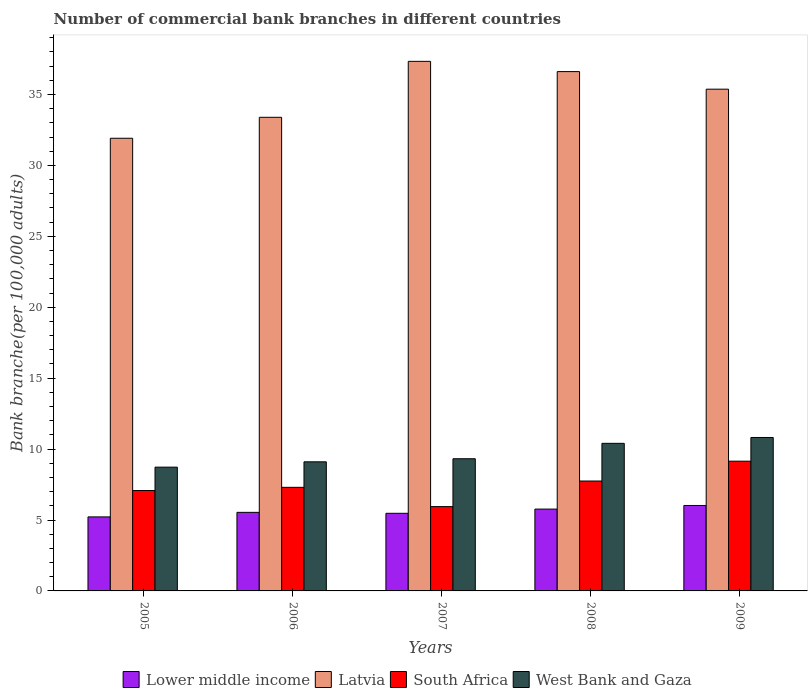Are the number of bars per tick equal to the number of legend labels?
Provide a succinct answer. Yes. Are the number of bars on each tick of the X-axis equal?
Offer a very short reply. Yes. How many bars are there on the 1st tick from the left?
Keep it short and to the point. 4. How many bars are there on the 5th tick from the right?
Offer a very short reply. 4. What is the label of the 2nd group of bars from the left?
Ensure brevity in your answer.  2006. What is the number of commercial bank branches in South Africa in 2006?
Keep it short and to the point. 7.3. Across all years, what is the maximum number of commercial bank branches in Latvia?
Your response must be concise. 37.34. Across all years, what is the minimum number of commercial bank branches in West Bank and Gaza?
Your response must be concise. 8.73. What is the total number of commercial bank branches in South Africa in the graph?
Your response must be concise. 37.22. What is the difference between the number of commercial bank branches in South Africa in 2005 and that in 2009?
Offer a very short reply. -2.07. What is the difference between the number of commercial bank branches in Latvia in 2008 and the number of commercial bank branches in West Bank and Gaza in 2005?
Offer a very short reply. 27.89. What is the average number of commercial bank branches in Lower middle income per year?
Give a very brief answer. 5.6. In the year 2007, what is the difference between the number of commercial bank branches in West Bank and Gaza and number of commercial bank branches in South Africa?
Offer a terse response. 3.38. What is the ratio of the number of commercial bank branches in South Africa in 2007 to that in 2009?
Make the answer very short. 0.65. Is the number of commercial bank branches in Latvia in 2007 less than that in 2008?
Your response must be concise. No. Is the difference between the number of commercial bank branches in West Bank and Gaza in 2005 and 2009 greater than the difference between the number of commercial bank branches in South Africa in 2005 and 2009?
Make the answer very short. No. What is the difference between the highest and the second highest number of commercial bank branches in Latvia?
Offer a terse response. 0.72. What is the difference between the highest and the lowest number of commercial bank branches in South Africa?
Keep it short and to the point. 3.2. What does the 2nd bar from the left in 2009 represents?
Give a very brief answer. Latvia. What does the 4th bar from the right in 2006 represents?
Provide a short and direct response. Lower middle income. How many bars are there?
Make the answer very short. 20. Are the values on the major ticks of Y-axis written in scientific E-notation?
Your answer should be very brief. No. Does the graph contain grids?
Keep it short and to the point. No. Where does the legend appear in the graph?
Provide a short and direct response. Bottom center. How many legend labels are there?
Your answer should be compact. 4. What is the title of the graph?
Keep it short and to the point. Number of commercial bank branches in different countries. Does "Togo" appear as one of the legend labels in the graph?
Offer a terse response. No. What is the label or title of the X-axis?
Offer a very short reply. Years. What is the label or title of the Y-axis?
Offer a terse response. Bank branche(per 100,0 adults). What is the Bank branche(per 100,000 adults) of Lower middle income in 2005?
Give a very brief answer. 5.22. What is the Bank branche(per 100,000 adults) in Latvia in 2005?
Provide a succinct answer. 31.92. What is the Bank branche(per 100,000 adults) of South Africa in 2005?
Ensure brevity in your answer.  7.08. What is the Bank branche(per 100,000 adults) in West Bank and Gaza in 2005?
Your answer should be compact. 8.73. What is the Bank branche(per 100,000 adults) of Lower middle income in 2006?
Give a very brief answer. 5.54. What is the Bank branche(per 100,000 adults) of Latvia in 2006?
Offer a very short reply. 33.39. What is the Bank branche(per 100,000 adults) of South Africa in 2006?
Keep it short and to the point. 7.3. What is the Bank branche(per 100,000 adults) in West Bank and Gaza in 2006?
Provide a succinct answer. 9.1. What is the Bank branche(per 100,000 adults) of Lower middle income in 2007?
Offer a terse response. 5.47. What is the Bank branche(per 100,000 adults) of Latvia in 2007?
Offer a very short reply. 37.34. What is the Bank branche(per 100,000 adults) of South Africa in 2007?
Offer a very short reply. 5.94. What is the Bank branche(per 100,000 adults) in West Bank and Gaza in 2007?
Offer a terse response. 9.32. What is the Bank branche(per 100,000 adults) in Lower middle income in 2008?
Provide a short and direct response. 5.77. What is the Bank branche(per 100,000 adults) of Latvia in 2008?
Offer a terse response. 36.62. What is the Bank branche(per 100,000 adults) in South Africa in 2008?
Your answer should be compact. 7.75. What is the Bank branche(per 100,000 adults) of West Bank and Gaza in 2008?
Provide a short and direct response. 10.41. What is the Bank branche(per 100,000 adults) of Lower middle income in 2009?
Keep it short and to the point. 6.02. What is the Bank branche(per 100,000 adults) of Latvia in 2009?
Provide a short and direct response. 35.38. What is the Bank branche(per 100,000 adults) of South Africa in 2009?
Keep it short and to the point. 9.15. What is the Bank branche(per 100,000 adults) of West Bank and Gaza in 2009?
Your answer should be compact. 10.82. Across all years, what is the maximum Bank branche(per 100,000 adults) in Lower middle income?
Your answer should be compact. 6.02. Across all years, what is the maximum Bank branche(per 100,000 adults) of Latvia?
Provide a succinct answer. 37.34. Across all years, what is the maximum Bank branche(per 100,000 adults) in South Africa?
Give a very brief answer. 9.15. Across all years, what is the maximum Bank branche(per 100,000 adults) of West Bank and Gaza?
Offer a very short reply. 10.82. Across all years, what is the minimum Bank branche(per 100,000 adults) of Lower middle income?
Offer a very short reply. 5.22. Across all years, what is the minimum Bank branche(per 100,000 adults) in Latvia?
Your answer should be very brief. 31.92. Across all years, what is the minimum Bank branche(per 100,000 adults) in South Africa?
Provide a short and direct response. 5.94. Across all years, what is the minimum Bank branche(per 100,000 adults) of West Bank and Gaza?
Provide a succinct answer. 8.73. What is the total Bank branche(per 100,000 adults) in Lower middle income in the graph?
Ensure brevity in your answer.  28.02. What is the total Bank branche(per 100,000 adults) of Latvia in the graph?
Your answer should be very brief. 174.64. What is the total Bank branche(per 100,000 adults) in South Africa in the graph?
Your answer should be compact. 37.22. What is the total Bank branche(per 100,000 adults) of West Bank and Gaza in the graph?
Offer a very short reply. 48.37. What is the difference between the Bank branche(per 100,000 adults) in Lower middle income in 2005 and that in 2006?
Your answer should be compact. -0.32. What is the difference between the Bank branche(per 100,000 adults) of Latvia in 2005 and that in 2006?
Your response must be concise. -1.48. What is the difference between the Bank branche(per 100,000 adults) in South Africa in 2005 and that in 2006?
Your answer should be compact. -0.23. What is the difference between the Bank branche(per 100,000 adults) in West Bank and Gaza in 2005 and that in 2006?
Your response must be concise. -0.37. What is the difference between the Bank branche(per 100,000 adults) in Lower middle income in 2005 and that in 2007?
Keep it short and to the point. -0.25. What is the difference between the Bank branche(per 100,000 adults) of Latvia in 2005 and that in 2007?
Give a very brief answer. -5.42. What is the difference between the Bank branche(per 100,000 adults) in South Africa in 2005 and that in 2007?
Keep it short and to the point. 1.13. What is the difference between the Bank branche(per 100,000 adults) in West Bank and Gaza in 2005 and that in 2007?
Give a very brief answer. -0.59. What is the difference between the Bank branche(per 100,000 adults) in Lower middle income in 2005 and that in 2008?
Your response must be concise. -0.55. What is the difference between the Bank branche(per 100,000 adults) of Latvia in 2005 and that in 2008?
Keep it short and to the point. -4.7. What is the difference between the Bank branche(per 100,000 adults) in South Africa in 2005 and that in 2008?
Keep it short and to the point. -0.67. What is the difference between the Bank branche(per 100,000 adults) of West Bank and Gaza in 2005 and that in 2008?
Your answer should be very brief. -1.68. What is the difference between the Bank branche(per 100,000 adults) of Lower middle income in 2005 and that in 2009?
Your answer should be very brief. -0.81. What is the difference between the Bank branche(per 100,000 adults) of Latvia in 2005 and that in 2009?
Provide a succinct answer. -3.46. What is the difference between the Bank branche(per 100,000 adults) in South Africa in 2005 and that in 2009?
Provide a short and direct response. -2.07. What is the difference between the Bank branche(per 100,000 adults) in West Bank and Gaza in 2005 and that in 2009?
Provide a succinct answer. -2.09. What is the difference between the Bank branche(per 100,000 adults) of Lower middle income in 2006 and that in 2007?
Make the answer very short. 0.07. What is the difference between the Bank branche(per 100,000 adults) of Latvia in 2006 and that in 2007?
Give a very brief answer. -3.94. What is the difference between the Bank branche(per 100,000 adults) of South Africa in 2006 and that in 2007?
Your answer should be compact. 1.36. What is the difference between the Bank branche(per 100,000 adults) of West Bank and Gaza in 2006 and that in 2007?
Offer a terse response. -0.22. What is the difference between the Bank branche(per 100,000 adults) of Lower middle income in 2006 and that in 2008?
Provide a succinct answer. -0.23. What is the difference between the Bank branche(per 100,000 adults) of Latvia in 2006 and that in 2008?
Offer a terse response. -3.22. What is the difference between the Bank branche(per 100,000 adults) in South Africa in 2006 and that in 2008?
Give a very brief answer. -0.45. What is the difference between the Bank branche(per 100,000 adults) in West Bank and Gaza in 2006 and that in 2008?
Offer a very short reply. -1.3. What is the difference between the Bank branche(per 100,000 adults) of Lower middle income in 2006 and that in 2009?
Offer a very short reply. -0.48. What is the difference between the Bank branche(per 100,000 adults) in Latvia in 2006 and that in 2009?
Make the answer very short. -1.98. What is the difference between the Bank branche(per 100,000 adults) in South Africa in 2006 and that in 2009?
Keep it short and to the point. -1.84. What is the difference between the Bank branche(per 100,000 adults) of West Bank and Gaza in 2006 and that in 2009?
Your answer should be compact. -1.72. What is the difference between the Bank branche(per 100,000 adults) of Lower middle income in 2007 and that in 2008?
Offer a very short reply. -0.3. What is the difference between the Bank branche(per 100,000 adults) in Latvia in 2007 and that in 2008?
Ensure brevity in your answer.  0.72. What is the difference between the Bank branche(per 100,000 adults) of South Africa in 2007 and that in 2008?
Make the answer very short. -1.8. What is the difference between the Bank branche(per 100,000 adults) in West Bank and Gaza in 2007 and that in 2008?
Your answer should be compact. -1.09. What is the difference between the Bank branche(per 100,000 adults) in Lower middle income in 2007 and that in 2009?
Offer a terse response. -0.55. What is the difference between the Bank branche(per 100,000 adults) in Latvia in 2007 and that in 2009?
Provide a succinct answer. 1.96. What is the difference between the Bank branche(per 100,000 adults) in South Africa in 2007 and that in 2009?
Offer a terse response. -3.2. What is the difference between the Bank branche(per 100,000 adults) of West Bank and Gaza in 2007 and that in 2009?
Your response must be concise. -1.5. What is the difference between the Bank branche(per 100,000 adults) in Lower middle income in 2008 and that in 2009?
Offer a very short reply. -0.25. What is the difference between the Bank branche(per 100,000 adults) in Latvia in 2008 and that in 2009?
Give a very brief answer. 1.24. What is the difference between the Bank branche(per 100,000 adults) in South Africa in 2008 and that in 2009?
Keep it short and to the point. -1.4. What is the difference between the Bank branche(per 100,000 adults) of West Bank and Gaza in 2008 and that in 2009?
Your answer should be compact. -0.41. What is the difference between the Bank branche(per 100,000 adults) in Lower middle income in 2005 and the Bank branche(per 100,000 adults) in Latvia in 2006?
Make the answer very short. -28.17. What is the difference between the Bank branche(per 100,000 adults) of Lower middle income in 2005 and the Bank branche(per 100,000 adults) of South Africa in 2006?
Make the answer very short. -2.08. What is the difference between the Bank branche(per 100,000 adults) in Lower middle income in 2005 and the Bank branche(per 100,000 adults) in West Bank and Gaza in 2006?
Your answer should be compact. -3.88. What is the difference between the Bank branche(per 100,000 adults) in Latvia in 2005 and the Bank branche(per 100,000 adults) in South Africa in 2006?
Your answer should be very brief. 24.61. What is the difference between the Bank branche(per 100,000 adults) of Latvia in 2005 and the Bank branche(per 100,000 adults) of West Bank and Gaza in 2006?
Keep it short and to the point. 22.81. What is the difference between the Bank branche(per 100,000 adults) in South Africa in 2005 and the Bank branche(per 100,000 adults) in West Bank and Gaza in 2006?
Provide a short and direct response. -2.02. What is the difference between the Bank branche(per 100,000 adults) of Lower middle income in 2005 and the Bank branche(per 100,000 adults) of Latvia in 2007?
Provide a short and direct response. -32.12. What is the difference between the Bank branche(per 100,000 adults) of Lower middle income in 2005 and the Bank branche(per 100,000 adults) of South Africa in 2007?
Make the answer very short. -0.73. What is the difference between the Bank branche(per 100,000 adults) of Lower middle income in 2005 and the Bank branche(per 100,000 adults) of West Bank and Gaza in 2007?
Offer a very short reply. -4.1. What is the difference between the Bank branche(per 100,000 adults) of Latvia in 2005 and the Bank branche(per 100,000 adults) of South Africa in 2007?
Give a very brief answer. 25.97. What is the difference between the Bank branche(per 100,000 adults) of Latvia in 2005 and the Bank branche(per 100,000 adults) of West Bank and Gaza in 2007?
Make the answer very short. 22.6. What is the difference between the Bank branche(per 100,000 adults) in South Africa in 2005 and the Bank branche(per 100,000 adults) in West Bank and Gaza in 2007?
Your answer should be compact. -2.24. What is the difference between the Bank branche(per 100,000 adults) of Lower middle income in 2005 and the Bank branche(per 100,000 adults) of Latvia in 2008?
Ensure brevity in your answer.  -31.4. What is the difference between the Bank branche(per 100,000 adults) in Lower middle income in 2005 and the Bank branche(per 100,000 adults) in South Africa in 2008?
Ensure brevity in your answer.  -2.53. What is the difference between the Bank branche(per 100,000 adults) of Lower middle income in 2005 and the Bank branche(per 100,000 adults) of West Bank and Gaza in 2008?
Offer a very short reply. -5.19. What is the difference between the Bank branche(per 100,000 adults) of Latvia in 2005 and the Bank branche(per 100,000 adults) of South Africa in 2008?
Give a very brief answer. 24.17. What is the difference between the Bank branche(per 100,000 adults) of Latvia in 2005 and the Bank branche(per 100,000 adults) of West Bank and Gaza in 2008?
Your response must be concise. 21.51. What is the difference between the Bank branche(per 100,000 adults) of South Africa in 2005 and the Bank branche(per 100,000 adults) of West Bank and Gaza in 2008?
Your answer should be very brief. -3.33. What is the difference between the Bank branche(per 100,000 adults) of Lower middle income in 2005 and the Bank branche(per 100,000 adults) of Latvia in 2009?
Provide a succinct answer. -30.16. What is the difference between the Bank branche(per 100,000 adults) of Lower middle income in 2005 and the Bank branche(per 100,000 adults) of South Africa in 2009?
Give a very brief answer. -3.93. What is the difference between the Bank branche(per 100,000 adults) in Latvia in 2005 and the Bank branche(per 100,000 adults) in South Africa in 2009?
Your answer should be compact. 22.77. What is the difference between the Bank branche(per 100,000 adults) in Latvia in 2005 and the Bank branche(per 100,000 adults) in West Bank and Gaza in 2009?
Make the answer very short. 21.1. What is the difference between the Bank branche(per 100,000 adults) in South Africa in 2005 and the Bank branche(per 100,000 adults) in West Bank and Gaza in 2009?
Ensure brevity in your answer.  -3.74. What is the difference between the Bank branche(per 100,000 adults) of Lower middle income in 2006 and the Bank branche(per 100,000 adults) of Latvia in 2007?
Give a very brief answer. -31.8. What is the difference between the Bank branche(per 100,000 adults) in Lower middle income in 2006 and the Bank branche(per 100,000 adults) in South Africa in 2007?
Offer a terse response. -0.4. What is the difference between the Bank branche(per 100,000 adults) in Lower middle income in 2006 and the Bank branche(per 100,000 adults) in West Bank and Gaza in 2007?
Offer a very short reply. -3.78. What is the difference between the Bank branche(per 100,000 adults) of Latvia in 2006 and the Bank branche(per 100,000 adults) of South Africa in 2007?
Offer a terse response. 27.45. What is the difference between the Bank branche(per 100,000 adults) of Latvia in 2006 and the Bank branche(per 100,000 adults) of West Bank and Gaza in 2007?
Your answer should be very brief. 24.07. What is the difference between the Bank branche(per 100,000 adults) in South Africa in 2006 and the Bank branche(per 100,000 adults) in West Bank and Gaza in 2007?
Offer a terse response. -2.02. What is the difference between the Bank branche(per 100,000 adults) in Lower middle income in 2006 and the Bank branche(per 100,000 adults) in Latvia in 2008?
Your response must be concise. -31.08. What is the difference between the Bank branche(per 100,000 adults) of Lower middle income in 2006 and the Bank branche(per 100,000 adults) of South Africa in 2008?
Make the answer very short. -2.21. What is the difference between the Bank branche(per 100,000 adults) of Lower middle income in 2006 and the Bank branche(per 100,000 adults) of West Bank and Gaza in 2008?
Provide a short and direct response. -4.87. What is the difference between the Bank branche(per 100,000 adults) in Latvia in 2006 and the Bank branche(per 100,000 adults) in South Africa in 2008?
Ensure brevity in your answer.  25.64. What is the difference between the Bank branche(per 100,000 adults) in Latvia in 2006 and the Bank branche(per 100,000 adults) in West Bank and Gaza in 2008?
Your answer should be very brief. 22.99. What is the difference between the Bank branche(per 100,000 adults) in South Africa in 2006 and the Bank branche(per 100,000 adults) in West Bank and Gaza in 2008?
Give a very brief answer. -3.1. What is the difference between the Bank branche(per 100,000 adults) of Lower middle income in 2006 and the Bank branche(per 100,000 adults) of Latvia in 2009?
Offer a terse response. -29.84. What is the difference between the Bank branche(per 100,000 adults) of Lower middle income in 2006 and the Bank branche(per 100,000 adults) of South Africa in 2009?
Give a very brief answer. -3.61. What is the difference between the Bank branche(per 100,000 adults) in Lower middle income in 2006 and the Bank branche(per 100,000 adults) in West Bank and Gaza in 2009?
Ensure brevity in your answer.  -5.28. What is the difference between the Bank branche(per 100,000 adults) in Latvia in 2006 and the Bank branche(per 100,000 adults) in South Africa in 2009?
Ensure brevity in your answer.  24.25. What is the difference between the Bank branche(per 100,000 adults) of Latvia in 2006 and the Bank branche(per 100,000 adults) of West Bank and Gaza in 2009?
Provide a short and direct response. 22.57. What is the difference between the Bank branche(per 100,000 adults) of South Africa in 2006 and the Bank branche(per 100,000 adults) of West Bank and Gaza in 2009?
Offer a very short reply. -3.52. What is the difference between the Bank branche(per 100,000 adults) in Lower middle income in 2007 and the Bank branche(per 100,000 adults) in Latvia in 2008?
Keep it short and to the point. -31.14. What is the difference between the Bank branche(per 100,000 adults) of Lower middle income in 2007 and the Bank branche(per 100,000 adults) of South Africa in 2008?
Your answer should be very brief. -2.28. What is the difference between the Bank branche(per 100,000 adults) of Lower middle income in 2007 and the Bank branche(per 100,000 adults) of West Bank and Gaza in 2008?
Keep it short and to the point. -4.93. What is the difference between the Bank branche(per 100,000 adults) in Latvia in 2007 and the Bank branche(per 100,000 adults) in South Africa in 2008?
Keep it short and to the point. 29.59. What is the difference between the Bank branche(per 100,000 adults) in Latvia in 2007 and the Bank branche(per 100,000 adults) in West Bank and Gaza in 2008?
Make the answer very short. 26.93. What is the difference between the Bank branche(per 100,000 adults) in South Africa in 2007 and the Bank branche(per 100,000 adults) in West Bank and Gaza in 2008?
Ensure brevity in your answer.  -4.46. What is the difference between the Bank branche(per 100,000 adults) in Lower middle income in 2007 and the Bank branche(per 100,000 adults) in Latvia in 2009?
Your answer should be very brief. -29.9. What is the difference between the Bank branche(per 100,000 adults) in Lower middle income in 2007 and the Bank branche(per 100,000 adults) in South Africa in 2009?
Your response must be concise. -3.68. What is the difference between the Bank branche(per 100,000 adults) of Lower middle income in 2007 and the Bank branche(per 100,000 adults) of West Bank and Gaza in 2009?
Provide a succinct answer. -5.35. What is the difference between the Bank branche(per 100,000 adults) in Latvia in 2007 and the Bank branche(per 100,000 adults) in South Africa in 2009?
Make the answer very short. 28.19. What is the difference between the Bank branche(per 100,000 adults) of Latvia in 2007 and the Bank branche(per 100,000 adults) of West Bank and Gaza in 2009?
Offer a terse response. 26.52. What is the difference between the Bank branche(per 100,000 adults) of South Africa in 2007 and the Bank branche(per 100,000 adults) of West Bank and Gaza in 2009?
Offer a very short reply. -4.87. What is the difference between the Bank branche(per 100,000 adults) of Lower middle income in 2008 and the Bank branche(per 100,000 adults) of Latvia in 2009?
Offer a terse response. -29.61. What is the difference between the Bank branche(per 100,000 adults) of Lower middle income in 2008 and the Bank branche(per 100,000 adults) of South Africa in 2009?
Provide a succinct answer. -3.38. What is the difference between the Bank branche(per 100,000 adults) in Lower middle income in 2008 and the Bank branche(per 100,000 adults) in West Bank and Gaza in 2009?
Provide a succinct answer. -5.05. What is the difference between the Bank branche(per 100,000 adults) of Latvia in 2008 and the Bank branche(per 100,000 adults) of South Africa in 2009?
Your answer should be very brief. 27.47. What is the difference between the Bank branche(per 100,000 adults) in Latvia in 2008 and the Bank branche(per 100,000 adults) in West Bank and Gaza in 2009?
Provide a succinct answer. 25.8. What is the difference between the Bank branche(per 100,000 adults) in South Africa in 2008 and the Bank branche(per 100,000 adults) in West Bank and Gaza in 2009?
Offer a very short reply. -3.07. What is the average Bank branche(per 100,000 adults) of Lower middle income per year?
Provide a succinct answer. 5.61. What is the average Bank branche(per 100,000 adults) in Latvia per year?
Offer a very short reply. 34.93. What is the average Bank branche(per 100,000 adults) of South Africa per year?
Offer a very short reply. 7.44. What is the average Bank branche(per 100,000 adults) of West Bank and Gaza per year?
Offer a terse response. 9.67. In the year 2005, what is the difference between the Bank branche(per 100,000 adults) in Lower middle income and Bank branche(per 100,000 adults) in Latvia?
Provide a short and direct response. -26.7. In the year 2005, what is the difference between the Bank branche(per 100,000 adults) in Lower middle income and Bank branche(per 100,000 adults) in South Africa?
Give a very brief answer. -1.86. In the year 2005, what is the difference between the Bank branche(per 100,000 adults) of Lower middle income and Bank branche(per 100,000 adults) of West Bank and Gaza?
Offer a very short reply. -3.51. In the year 2005, what is the difference between the Bank branche(per 100,000 adults) in Latvia and Bank branche(per 100,000 adults) in South Africa?
Provide a short and direct response. 24.84. In the year 2005, what is the difference between the Bank branche(per 100,000 adults) in Latvia and Bank branche(per 100,000 adults) in West Bank and Gaza?
Provide a short and direct response. 23.19. In the year 2005, what is the difference between the Bank branche(per 100,000 adults) in South Africa and Bank branche(per 100,000 adults) in West Bank and Gaza?
Offer a very short reply. -1.65. In the year 2006, what is the difference between the Bank branche(per 100,000 adults) of Lower middle income and Bank branche(per 100,000 adults) of Latvia?
Ensure brevity in your answer.  -27.85. In the year 2006, what is the difference between the Bank branche(per 100,000 adults) of Lower middle income and Bank branche(per 100,000 adults) of South Africa?
Ensure brevity in your answer.  -1.76. In the year 2006, what is the difference between the Bank branche(per 100,000 adults) in Lower middle income and Bank branche(per 100,000 adults) in West Bank and Gaza?
Your answer should be compact. -3.56. In the year 2006, what is the difference between the Bank branche(per 100,000 adults) of Latvia and Bank branche(per 100,000 adults) of South Africa?
Offer a very short reply. 26.09. In the year 2006, what is the difference between the Bank branche(per 100,000 adults) in Latvia and Bank branche(per 100,000 adults) in West Bank and Gaza?
Give a very brief answer. 24.29. In the year 2006, what is the difference between the Bank branche(per 100,000 adults) of South Africa and Bank branche(per 100,000 adults) of West Bank and Gaza?
Your answer should be compact. -1.8. In the year 2007, what is the difference between the Bank branche(per 100,000 adults) in Lower middle income and Bank branche(per 100,000 adults) in Latvia?
Keep it short and to the point. -31.87. In the year 2007, what is the difference between the Bank branche(per 100,000 adults) in Lower middle income and Bank branche(per 100,000 adults) in South Africa?
Ensure brevity in your answer.  -0.47. In the year 2007, what is the difference between the Bank branche(per 100,000 adults) in Lower middle income and Bank branche(per 100,000 adults) in West Bank and Gaza?
Give a very brief answer. -3.85. In the year 2007, what is the difference between the Bank branche(per 100,000 adults) of Latvia and Bank branche(per 100,000 adults) of South Africa?
Offer a terse response. 31.39. In the year 2007, what is the difference between the Bank branche(per 100,000 adults) of Latvia and Bank branche(per 100,000 adults) of West Bank and Gaza?
Your answer should be very brief. 28.02. In the year 2007, what is the difference between the Bank branche(per 100,000 adults) in South Africa and Bank branche(per 100,000 adults) in West Bank and Gaza?
Make the answer very short. -3.38. In the year 2008, what is the difference between the Bank branche(per 100,000 adults) of Lower middle income and Bank branche(per 100,000 adults) of Latvia?
Give a very brief answer. -30.85. In the year 2008, what is the difference between the Bank branche(per 100,000 adults) in Lower middle income and Bank branche(per 100,000 adults) in South Africa?
Provide a succinct answer. -1.98. In the year 2008, what is the difference between the Bank branche(per 100,000 adults) of Lower middle income and Bank branche(per 100,000 adults) of West Bank and Gaza?
Give a very brief answer. -4.64. In the year 2008, what is the difference between the Bank branche(per 100,000 adults) in Latvia and Bank branche(per 100,000 adults) in South Africa?
Make the answer very short. 28.87. In the year 2008, what is the difference between the Bank branche(per 100,000 adults) of Latvia and Bank branche(per 100,000 adults) of West Bank and Gaza?
Provide a short and direct response. 26.21. In the year 2008, what is the difference between the Bank branche(per 100,000 adults) of South Africa and Bank branche(per 100,000 adults) of West Bank and Gaza?
Make the answer very short. -2.66. In the year 2009, what is the difference between the Bank branche(per 100,000 adults) in Lower middle income and Bank branche(per 100,000 adults) in Latvia?
Your answer should be compact. -29.35. In the year 2009, what is the difference between the Bank branche(per 100,000 adults) in Lower middle income and Bank branche(per 100,000 adults) in South Africa?
Your response must be concise. -3.12. In the year 2009, what is the difference between the Bank branche(per 100,000 adults) of Lower middle income and Bank branche(per 100,000 adults) of West Bank and Gaza?
Keep it short and to the point. -4.79. In the year 2009, what is the difference between the Bank branche(per 100,000 adults) of Latvia and Bank branche(per 100,000 adults) of South Africa?
Your response must be concise. 26.23. In the year 2009, what is the difference between the Bank branche(per 100,000 adults) of Latvia and Bank branche(per 100,000 adults) of West Bank and Gaza?
Ensure brevity in your answer.  24.56. In the year 2009, what is the difference between the Bank branche(per 100,000 adults) of South Africa and Bank branche(per 100,000 adults) of West Bank and Gaza?
Provide a succinct answer. -1.67. What is the ratio of the Bank branche(per 100,000 adults) of Lower middle income in 2005 to that in 2006?
Your answer should be very brief. 0.94. What is the ratio of the Bank branche(per 100,000 adults) in Latvia in 2005 to that in 2006?
Your answer should be compact. 0.96. What is the ratio of the Bank branche(per 100,000 adults) of South Africa in 2005 to that in 2006?
Give a very brief answer. 0.97. What is the ratio of the Bank branche(per 100,000 adults) of West Bank and Gaza in 2005 to that in 2006?
Provide a short and direct response. 0.96. What is the ratio of the Bank branche(per 100,000 adults) in Lower middle income in 2005 to that in 2007?
Make the answer very short. 0.95. What is the ratio of the Bank branche(per 100,000 adults) in Latvia in 2005 to that in 2007?
Keep it short and to the point. 0.85. What is the ratio of the Bank branche(per 100,000 adults) in South Africa in 2005 to that in 2007?
Your answer should be compact. 1.19. What is the ratio of the Bank branche(per 100,000 adults) of West Bank and Gaza in 2005 to that in 2007?
Provide a short and direct response. 0.94. What is the ratio of the Bank branche(per 100,000 adults) in Lower middle income in 2005 to that in 2008?
Provide a short and direct response. 0.9. What is the ratio of the Bank branche(per 100,000 adults) of Latvia in 2005 to that in 2008?
Offer a terse response. 0.87. What is the ratio of the Bank branche(per 100,000 adults) of South Africa in 2005 to that in 2008?
Your answer should be very brief. 0.91. What is the ratio of the Bank branche(per 100,000 adults) in West Bank and Gaza in 2005 to that in 2008?
Provide a succinct answer. 0.84. What is the ratio of the Bank branche(per 100,000 adults) of Lower middle income in 2005 to that in 2009?
Provide a succinct answer. 0.87. What is the ratio of the Bank branche(per 100,000 adults) in Latvia in 2005 to that in 2009?
Your answer should be compact. 0.9. What is the ratio of the Bank branche(per 100,000 adults) of South Africa in 2005 to that in 2009?
Provide a short and direct response. 0.77. What is the ratio of the Bank branche(per 100,000 adults) in West Bank and Gaza in 2005 to that in 2009?
Your answer should be compact. 0.81. What is the ratio of the Bank branche(per 100,000 adults) in Lower middle income in 2006 to that in 2007?
Make the answer very short. 1.01. What is the ratio of the Bank branche(per 100,000 adults) in Latvia in 2006 to that in 2007?
Keep it short and to the point. 0.89. What is the ratio of the Bank branche(per 100,000 adults) in South Africa in 2006 to that in 2007?
Ensure brevity in your answer.  1.23. What is the ratio of the Bank branche(per 100,000 adults) in West Bank and Gaza in 2006 to that in 2007?
Make the answer very short. 0.98. What is the ratio of the Bank branche(per 100,000 adults) of Lower middle income in 2006 to that in 2008?
Make the answer very short. 0.96. What is the ratio of the Bank branche(per 100,000 adults) in Latvia in 2006 to that in 2008?
Provide a succinct answer. 0.91. What is the ratio of the Bank branche(per 100,000 adults) in South Africa in 2006 to that in 2008?
Your answer should be very brief. 0.94. What is the ratio of the Bank branche(per 100,000 adults) of West Bank and Gaza in 2006 to that in 2008?
Give a very brief answer. 0.87. What is the ratio of the Bank branche(per 100,000 adults) of Lower middle income in 2006 to that in 2009?
Keep it short and to the point. 0.92. What is the ratio of the Bank branche(per 100,000 adults) in Latvia in 2006 to that in 2009?
Provide a short and direct response. 0.94. What is the ratio of the Bank branche(per 100,000 adults) in South Africa in 2006 to that in 2009?
Your answer should be very brief. 0.8. What is the ratio of the Bank branche(per 100,000 adults) in West Bank and Gaza in 2006 to that in 2009?
Make the answer very short. 0.84. What is the ratio of the Bank branche(per 100,000 adults) in Lower middle income in 2007 to that in 2008?
Provide a succinct answer. 0.95. What is the ratio of the Bank branche(per 100,000 adults) of Latvia in 2007 to that in 2008?
Offer a very short reply. 1.02. What is the ratio of the Bank branche(per 100,000 adults) of South Africa in 2007 to that in 2008?
Keep it short and to the point. 0.77. What is the ratio of the Bank branche(per 100,000 adults) of West Bank and Gaza in 2007 to that in 2008?
Offer a terse response. 0.9. What is the ratio of the Bank branche(per 100,000 adults) of Lower middle income in 2007 to that in 2009?
Give a very brief answer. 0.91. What is the ratio of the Bank branche(per 100,000 adults) of Latvia in 2007 to that in 2009?
Make the answer very short. 1.06. What is the ratio of the Bank branche(per 100,000 adults) in South Africa in 2007 to that in 2009?
Your response must be concise. 0.65. What is the ratio of the Bank branche(per 100,000 adults) in West Bank and Gaza in 2007 to that in 2009?
Offer a very short reply. 0.86. What is the ratio of the Bank branche(per 100,000 adults) in Lower middle income in 2008 to that in 2009?
Provide a succinct answer. 0.96. What is the ratio of the Bank branche(per 100,000 adults) of Latvia in 2008 to that in 2009?
Provide a succinct answer. 1.04. What is the ratio of the Bank branche(per 100,000 adults) in South Africa in 2008 to that in 2009?
Ensure brevity in your answer.  0.85. What is the ratio of the Bank branche(per 100,000 adults) of West Bank and Gaza in 2008 to that in 2009?
Provide a short and direct response. 0.96. What is the difference between the highest and the second highest Bank branche(per 100,000 adults) of Lower middle income?
Offer a very short reply. 0.25. What is the difference between the highest and the second highest Bank branche(per 100,000 adults) of Latvia?
Provide a short and direct response. 0.72. What is the difference between the highest and the second highest Bank branche(per 100,000 adults) in South Africa?
Provide a short and direct response. 1.4. What is the difference between the highest and the second highest Bank branche(per 100,000 adults) of West Bank and Gaza?
Offer a very short reply. 0.41. What is the difference between the highest and the lowest Bank branche(per 100,000 adults) in Lower middle income?
Your answer should be compact. 0.81. What is the difference between the highest and the lowest Bank branche(per 100,000 adults) in Latvia?
Offer a terse response. 5.42. What is the difference between the highest and the lowest Bank branche(per 100,000 adults) in South Africa?
Keep it short and to the point. 3.2. What is the difference between the highest and the lowest Bank branche(per 100,000 adults) in West Bank and Gaza?
Make the answer very short. 2.09. 